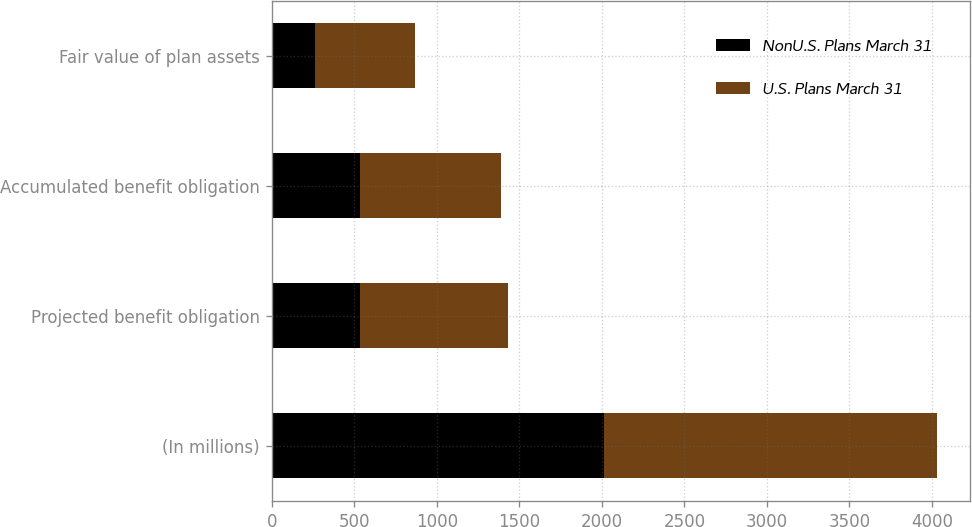<chart> <loc_0><loc_0><loc_500><loc_500><stacked_bar_chart><ecel><fcel>(In millions)<fcel>Projected benefit obligation<fcel>Accumulated benefit obligation<fcel>Fair value of plan assets<nl><fcel>NonU.S. Plans March 31<fcel>2016<fcel>535<fcel>535<fcel>262<nl><fcel>U.S. Plans March 31<fcel>2016<fcel>899<fcel>855<fcel>607<nl></chart> 